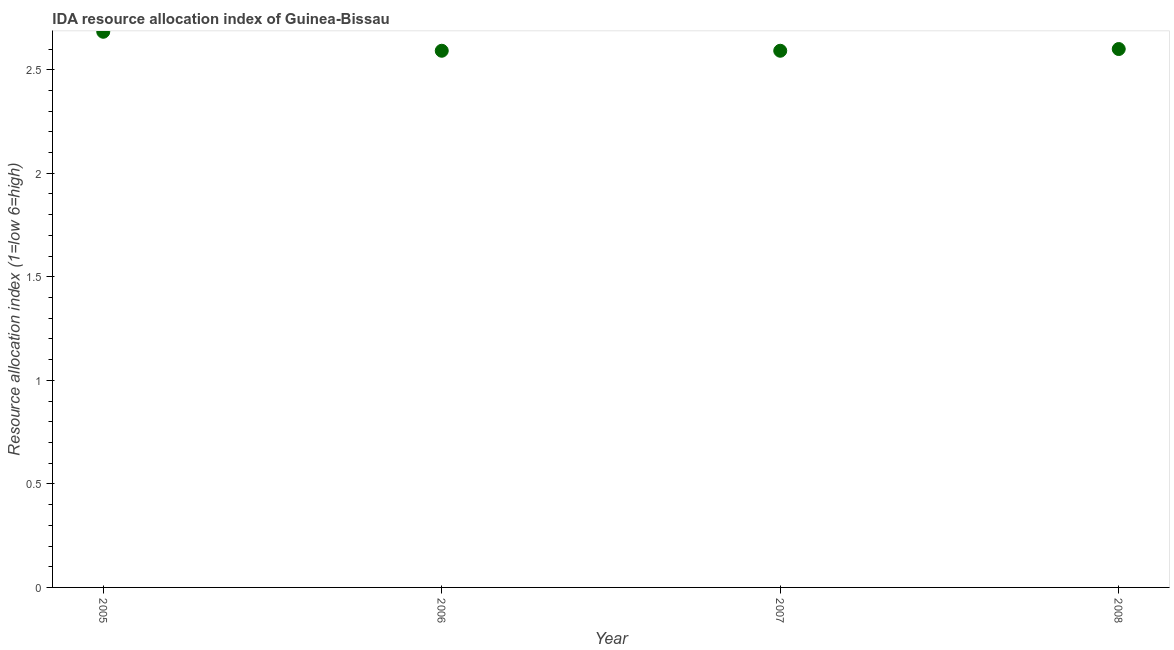What is the ida resource allocation index in 2006?
Offer a very short reply. 2.59. Across all years, what is the maximum ida resource allocation index?
Your answer should be very brief. 2.68. Across all years, what is the minimum ida resource allocation index?
Make the answer very short. 2.59. In which year was the ida resource allocation index minimum?
Offer a very short reply. 2006. What is the sum of the ida resource allocation index?
Provide a succinct answer. 10.47. What is the difference between the ida resource allocation index in 2006 and 2007?
Your answer should be compact. 0. What is the average ida resource allocation index per year?
Offer a terse response. 2.62. What is the median ida resource allocation index?
Your response must be concise. 2.6. In how many years, is the ida resource allocation index greater than 0.4 ?
Offer a terse response. 4. Do a majority of the years between 2005 and 2007 (inclusive) have ida resource allocation index greater than 0.4 ?
Make the answer very short. Yes. What is the ratio of the ida resource allocation index in 2005 to that in 2007?
Make the answer very short. 1.04. Is the difference between the ida resource allocation index in 2005 and 2006 greater than the difference between any two years?
Your answer should be very brief. Yes. What is the difference between the highest and the second highest ida resource allocation index?
Make the answer very short. 0.08. Is the sum of the ida resource allocation index in 2005 and 2008 greater than the maximum ida resource allocation index across all years?
Provide a short and direct response. Yes. What is the difference between the highest and the lowest ida resource allocation index?
Provide a succinct answer. 0.09. Does the ida resource allocation index monotonically increase over the years?
Your response must be concise. No. How many years are there in the graph?
Give a very brief answer. 4. What is the difference between two consecutive major ticks on the Y-axis?
Your response must be concise. 0.5. Does the graph contain grids?
Provide a succinct answer. No. What is the title of the graph?
Provide a succinct answer. IDA resource allocation index of Guinea-Bissau. What is the label or title of the X-axis?
Provide a short and direct response. Year. What is the label or title of the Y-axis?
Make the answer very short. Resource allocation index (1=low 6=high). What is the Resource allocation index (1=low 6=high) in 2005?
Give a very brief answer. 2.68. What is the Resource allocation index (1=low 6=high) in 2006?
Keep it short and to the point. 2.59. What is the Resource allocation index (1=low 6=high) in 2007?
Provide a succinct answer. 2.59. What is the difference between the Resource allocation index (1=low 6=high) in 2005 and 2006?
Ensure brevity in your answer.  0.09. What is the difference between the Resource allocation index (1=low 6=high) in 2005 and 2007?
Your answer should be compact. 0.09. What is the difference between the Resource allocation index (1=low 6=high) in 2005 and 2008?
Your answer should be very brief. 0.08. What is the difference between the Resource allocation index (1=low 6=high) in 2006 and 2007?
Provide a succinct answer. 0. What is the difference between the Resource allocation index (1=low 6=high) in 2006 and 2008?
Offer a very short reply. -0.01. What is the difference between the Resource allocation index (1=low 6=high) in 2007 and 2008?
Offer a terse response. -0.01. What is the ratio of the Resource allocation index (1=low 6=high) in 2005 to that in 2006?
Your answer should be very brief. 1.03. What is the ratio of the Resource allocation index (1=low 6=high) in 2005 to that in 2007?
Give a very brief answer. 1.03. What is the ratio of the Resource allocation index (1=low 6=high) in 2005 to that in 2008?
Your answer should be very brief. 1.03. What is the ratio of the Resource allocation index (1=low 6=high) in 2006 to that in 2007?
Offer a terse response. 1. What is the ratio of the Resource allocation index (1=low 6=high) in 2006 to that in 2008?
Your answer should be very brief. 1. What is the ratio of the Resource allocation index (1=low 6=high) in 2007 to that in 2008?
Provide a succinct answer. 1. 